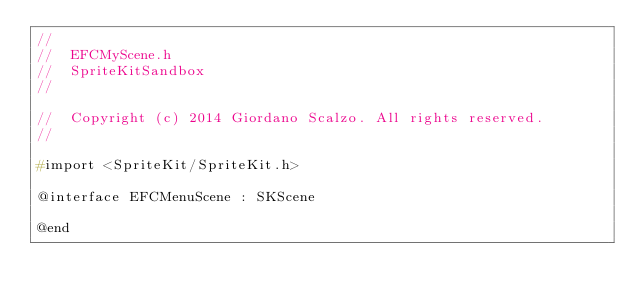Convert code to text. <code><loc_0><loc_0><loc_500><loc_500><_C_>//
//  EFCMyScene.h
//  SpriteKitSandbox
//

//  Copyright (c) 2014 Giordano Scalzo. All rights reserved.
//

#import <SpriteKit/SpriteKit.h>

@interface EFCMenuScene : SKScene

@end
</code> 